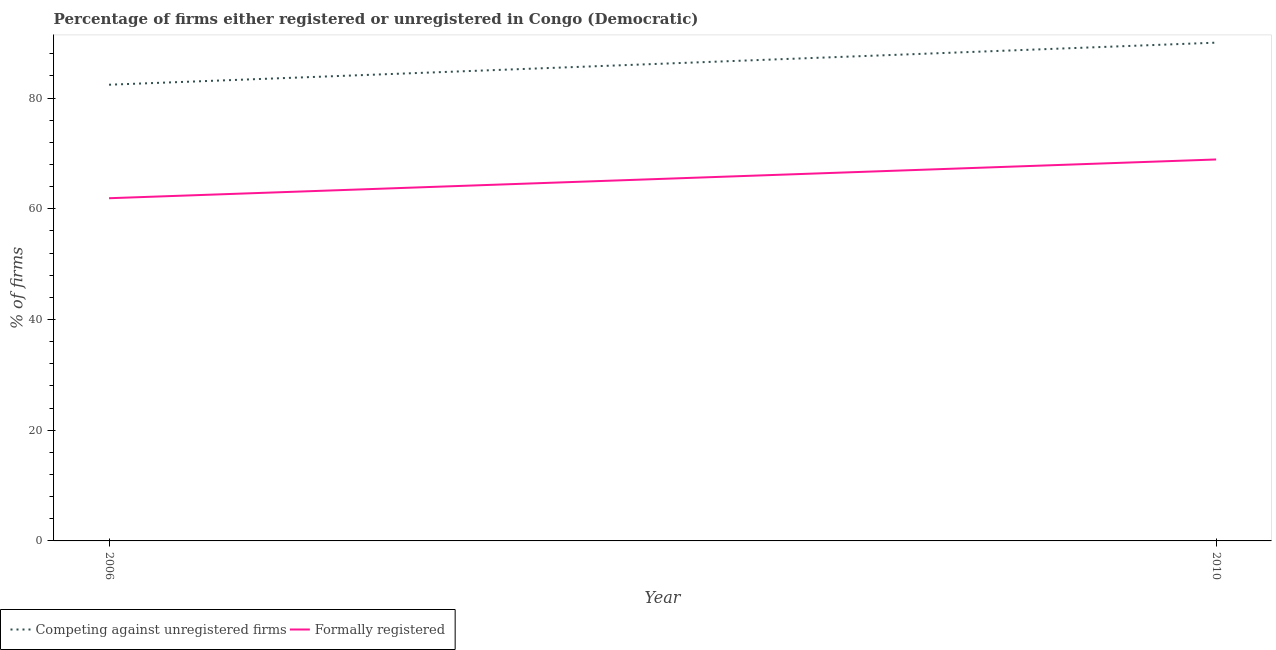How many different coloured lines are there?
Offer a very short reply. 2. Does the line corresponding to percentage of registered firms intersect with the line corresponding to percentage of formally registered firms?
Offer a terse response. No. Across all years, what is the maximum percentage of formally registered firms?
Your answer should be very brief. 68.9. Across all years, what is the minimum percentage of registered firms?
Offer a very short reply. 82.4. In which year was the percentage of registered firms minimum?
Give a very brief answer. 2006. What is the total percentage of formally registered firms in the graph?
Offer a terse response. 130.8. What is the difference between the percentage of formally registered firms in 2006 and that in 2010?
Offer a terse response. -7. What is the difference between the percentage of formally registered firms in 2006 and the percentage of registered firms in 2010?
Give a very brief answer. -28.1. What is the average percentage of formally registered firms per year?
Provide a short and direct response. 65.4. In the year 2006, what is the difference between the percentage of registered firms and percentage of formally registered firms?
Keep it short and to the point. 20.5. What is the ratio of the percentage of registered firms in 2006 to that in 2010?
Make the answer very short. 0.92. In how many years, is the percentage of formally registered firms greater than the average percentage of formally registered firms taken over all years?
Offer a terse response. 1. Does the percentage of registered firms monotonically increase over the years?
Keep it short and to the point. Yes. Is the percentage of formally registered firms strictly greater than the percentage of registered firms over the years?
Offer a very short reply. No. Is the percentage of registered firms strictly less than the percentage of formally registered firms over the years?
Your answer should be compact. No. How many years are there in the graph?
Offer a very short reply. 2. What is the title of the graph?
Provide a short and direct response. Percentage of firms either registered or unregistered in Congo (Democratic). Does "Transport services" appear as one of the legend labels in the graph?
Your answer should be very brief. No. What is the label or title of the Y-axis?
Give a very brief answer. % of firms. What is the % of firms of Competing against unregistered firms in 2006?
Your response must be concise. 82.4. What is the % of firms in Formally registered in 2006?
Give a very brief answer. 61.9. What is the % of firms of Formally registered in 2010?
Keep it short and to the point. 68.9. Across all years, what is the maximum % of firms in Formally registered?
Your answer should be compact. 68.9. Across all years, what is the minimum % of firms in Competing against unregistered firms?
Your response must be concise. 82.4. Across all years, what is the minimum % of firms in Formally registered?
Give a very brief answer. 61.9. What is the total % of firms of Competing against unregistered firms in the graph?
Make the answer very short. 172.4. What is the total % of firms in Formally registered in the graph?
Offer a terse response. 130.8. What is the difference between the % of firms of Competing against unregistered firms in 2006 and that in 2010?
Ensure brevity in your answer.  -7.6. What is the average % of firms of Competing against unregistered firms per year?
Ensure brevity in your answer.  86.2. What is the average % of firms in Formally registered per year?
Provide a short and direct response. 65.4. In the year 2010, what is the difference between the % of firms in Competing against unregistered firms and % of firms in Formally registered?
Your answer should be compact. 21.1. What is the ratio of the % of firms in Competing against unregistered firms in 2006 to that in 2010?
Keep it short and to the point. 0.92. What is the ratio of the % of firms in Formally registered in 2006 to that in 2010?
Give a very brief answer. 0.9. What is the difference between the highest and the second highest % of firms in Formally registered?
Give a very brief answer. 7. What is the difference between the highest and the lowest % of firms in Competing against unregistered firms?
Ensure brevity in your answer.  7.6. 